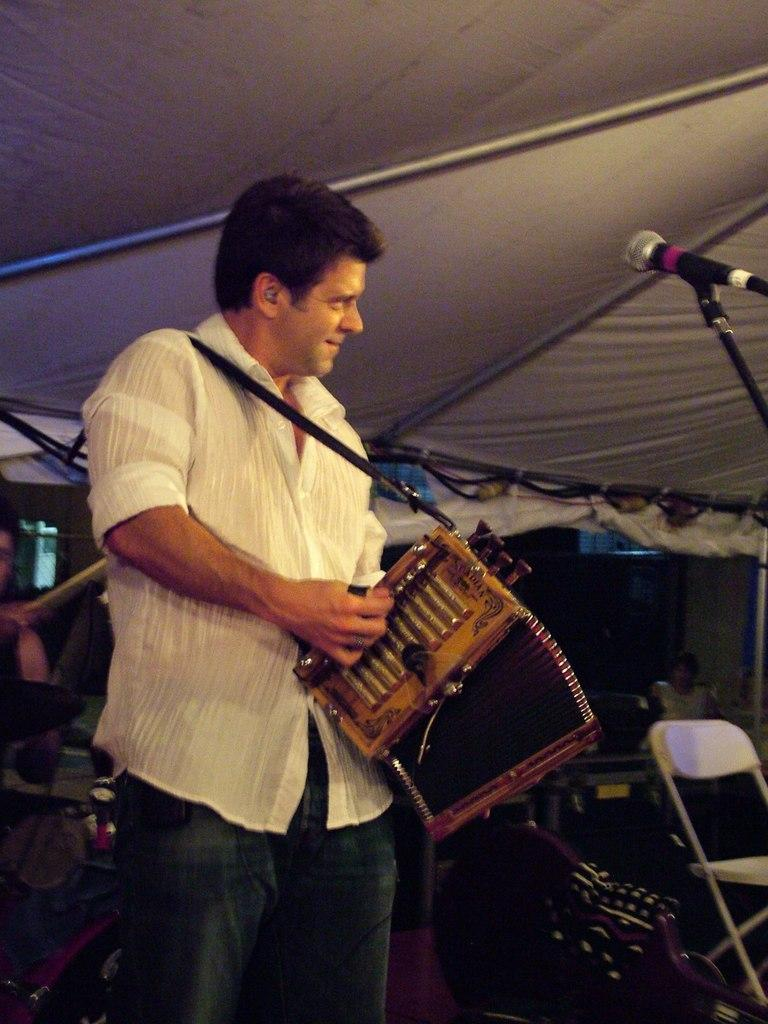Who or what is present in the image? There is a person in the image. What is the person doing or where are they located? The person is standing under a tent. What is the person holding? The person is holding a musical instrument. What can be seen on the right side of the image? There is a mic with a stand and a chair on the right side of the image. What type of horn can be seen on the person's head in the image? There is no horn present on the person's head in the image. 